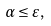Convert formula to latex. <formula><loc_0><loc_0><loc_500><loc_500>\alpha \leq \varepsilon ,</formula> 